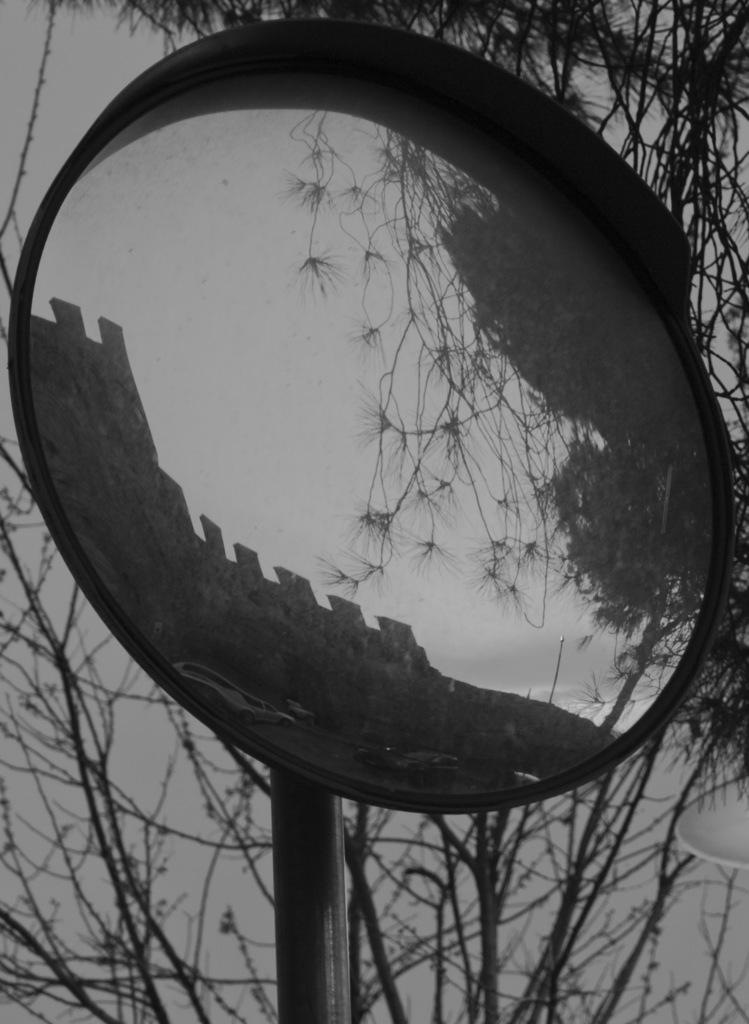What is the color scheme of the image? The image is black and white. What can be seen on a pole in the image? There is an object on a pole in the image. What type of natural elements can be seen in the background of the image? Branches of trees are visible in the background of the image. What type of toothpaste is being advertised on the object on the pole in the image? There is no toothpaste present in the image, and the object on the pole does not appear to be an advertisement. 